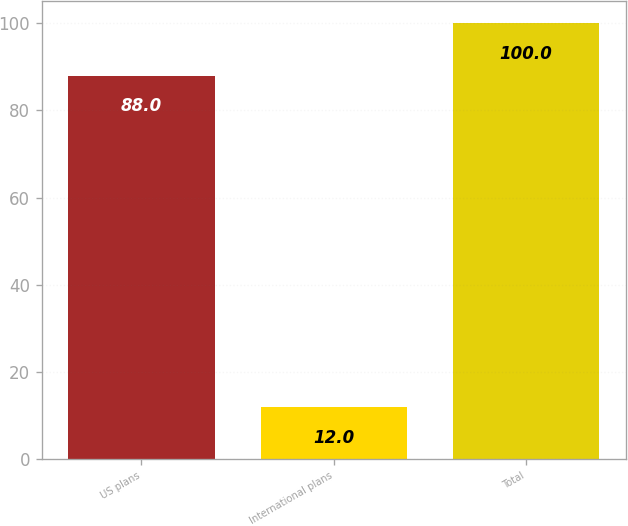<chart> <loc_0><loc_0><loc_500><loc_500><bar_chart><fcel>US plans<fcel>International plans<fcel>Total<nl><fcel>88<fcel>12<fcel>100<nl></chart> 